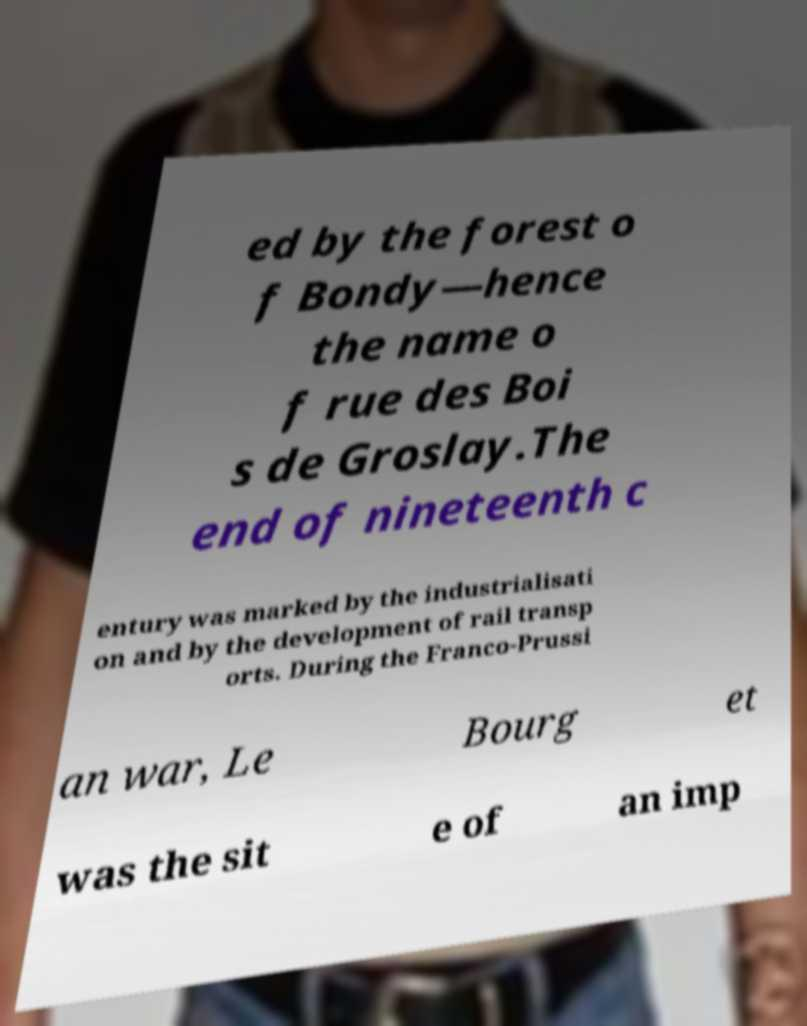There's text embedded in this image that I need extracted. Can you transcribe it verbatim? ed by the forest o f Bondy—hence the name o f rue des Boi s de Groslay.The end of nineteenth c entury was marked by the industrialisati on and by the development of rail transp orts. During the Franco-Prussi an war, Le Bourg et was the sit e of an imp 